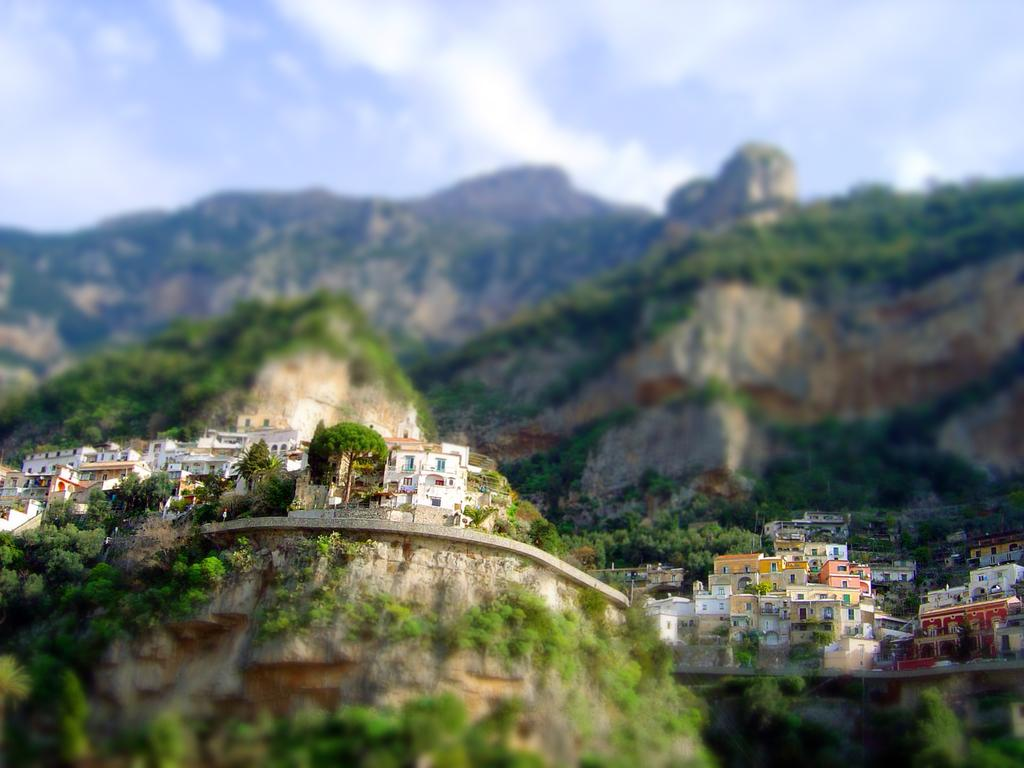What type of structures can be seen in the image? There are many buildings in the image. What other natural elements are present in the image? There are trees and mountains visible in the image. How would you describe the background of the image? The background has a blurred view. What part of the natural environment is visible in the image? The sky is visible at the top of the image. What type of ice can be seen melting on the animal's fur in the image? There is no ice or animal present in the image; it features buildings, trees, mountains, and a blurred background. 